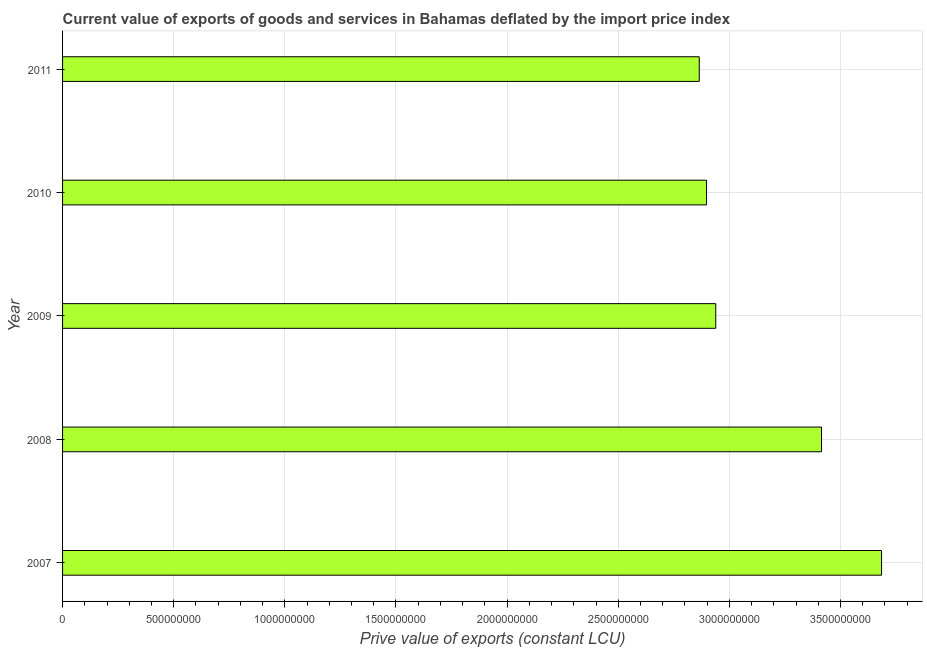Does the graph contain any zero values?
Offer a very short reply. No. What is the title of the graph?
Keep it short and to the point. Current value of exports of goods and services in Bahamas deflated by the import price index. What is the label or title of the X-axis?
Make the answer very short. Prive value of exports (constant LCU). What is the price value of exports in 2009?
Offer a terse response. 2.94e+09. Across all years, what is the maximum price value of exports?
Provide a short and direct response. 3.68e+09. Across all years, what is the minimum price value of exports?
Offer a very short reply. 2.86e+09. What is the sum of the price value of exports?
Your answer should be very brief. 1.58e+1. What is the difference between the price value of exports in 2007 and 2010?
Ensure brevity in your answer.  7.87e+08. What is the average price value of exports per year?
Give a very brief answer. 3.16e+09. What is the median price value of exports?
Your answer should be very brief. 2.94e+09. In how many years, is the price value of exports greater than 1500000000 LCU?
Keep it short and to the point. 5. Do a majority of the years between 2008 and 2007 (inclusive) have price value of exports greater than 400000000 LCU?
Your answer should be compact. No. What is the difference between the highest and the second highest price value of exports?
Your answer should be very brief. 2.70e+08. Is the sum of the price value of exports in 2007 and 2008 greater than the maximum price value of exports across all years?
Provide a short and direct response. Yes. What is the difference between the highest and the lowest price value of exports?
Offer a very short reply. 8.20e+08. In how many years, is the price value of exports greater than the average price value of exports taken over all years?
Make the answer very short. 2. Are all the bars in the graph horizontal?
Your response must be concise. Yes. What is the difference between two consecutive major ticks on the X-axis?
Give a very brief answer. 5.00e+08. What is the Prive value of exports (constant LCU) in 2007?
Offer a terse response. 3.68e+09. What is the Prive value of exports (constant LCU) in 2008?
Provide a short and direct response. 3.41e+09. What is the Prive value of exports (constant LCU) in 2009?
Make the answer very short. 2.94e+09. What is the Prive value of exports (constant LCU) of 2010?
Offer a terse response. 2.90e+09. What is the Prive value of exports (constant LCU) of 2011?
Provide a succinct answer. 2.86e+09. What is the difference between the Prive value of exports (constant LCU) in 2007 and 2008?
Offer a terse response. 2.70e+08. What is the difference between the Prive value of exports (constant LCU) in 2007 and 2009?
Keep it short and to the point. 7.46e+08. What is the difference between the Prive value of exports (constant LCU) in 2007 and 2010?
Offer a very short reply. 7.87e+08. What is the difference between the Prive value of exports (constant LCU) in 2007 and 2011?
Keep it short and to the point. 8.20e+08. What is the difference between the Prive value of exports (constant LCU) in 2008 and 2009?
Offer a very short reply. 4.76e+08. What is the difference between the Prive value of exports (constant LCU) in 2008 and 2010?
Your response must be concise. 5.17e+08. What is the difference between the Prive value of exports (constant LCU) in 2008 and 2011?
Provide a short and direct response. 5.50e+08. What is the difference between the Prive value of exports (constant LCU) in 2009 and 2010?
Give a very brief answer. 4.15e+07. What is the difference between the Prive value of exports (constant LCU) in 2009 and 2011?
Make the answer very short. 7.43e+07. What is the difference between the Prive value of exports (constant LCU) in 2010 and 2011?
Provide a succinct answer. 3.28e+07. What is the ratio of the Prive value of exports (constant LCU) in 2007 to that in 2008?
Give a very brief answer. 1.08. What is the ratio of the Prive value of exports (constant LCU) in 2007 to that in 2009?
Your answer should be very brief. 1.25. What is the ratio of the Prive value of exports (constant LCU) in 2007 to that in 2010?
Keep it short and to the point. 1.27. What is the ratio of the Prive value of exports (constant LCU) in 2007 to that in 2011?
Ensure brevity in your answer.  1.29. What is the ratio of the Prive value of exports (constant LCU) in 2008 to that in 2009?
Your response must be concise. 1.16. What is the ratio of the Prive value of exports (constant LCU) in 2008 to that in 2010?
Your answer should be very brief. 1.18. What is the ratio of the Prive value of exports (constant LCU) in 2008 to that in 2011?
Give a very brief answer. 1.19. 